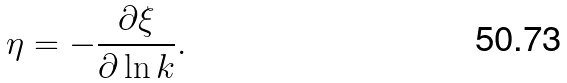Convert formula to latex. <formula><loc_0><loc_0><loc_500><loc_500>\eta = - \frac { \partial \xi } { \partial \ln k } .</formula> 